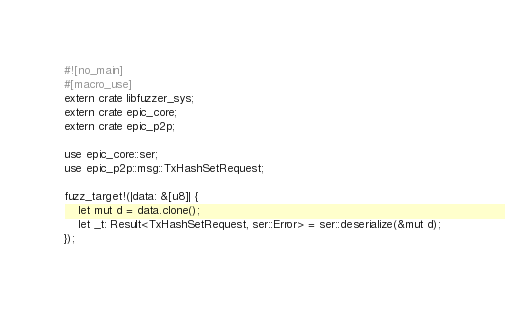Convert code to text. <code><loc_0><loc_0><loc_500><loc_500><_Rust_>#![no_main]
#[macro_use]
extern crate libfuzzer_sys;
extern crate epic_core;
extern crate epic_p2p;

use epic_core::ser;
use epic_p2p::msg::TxHashSetRequest;

fuzz_target!(|data: &[u8]| {
	let mut d = data.clone();
	let _t: Result<TxHashSetRequest, ser::Error> = ser::deserialize(&mut d);
});
</code> 